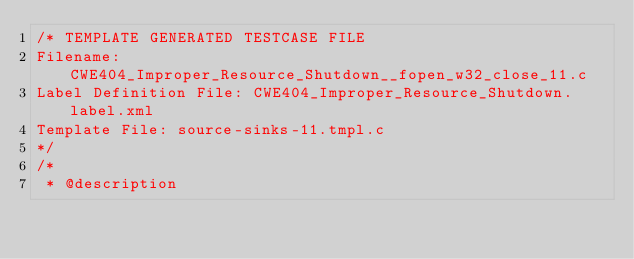Convert code to text. <code><loc_0><loc_0><loc_500><loc_500><_C_>/* TEMPLATE GENERATED TESTCASE FILE
Filename: CWE404_Improper_Resource_Shutdown__fopen_w32_close_11.c
Label Definition File: CWE404_Improper_Resource_Shutdown.label.xml
Template File: source-sinks-11.tmpl.c
*/
/*
 * @description</code> 